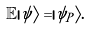Convert formula to latex. <formula><loc_0><loc_0><loc_500><loc_500>\mathbb { E } | \psi \rangle = | \psi _ { P } \rangle .</formula> 